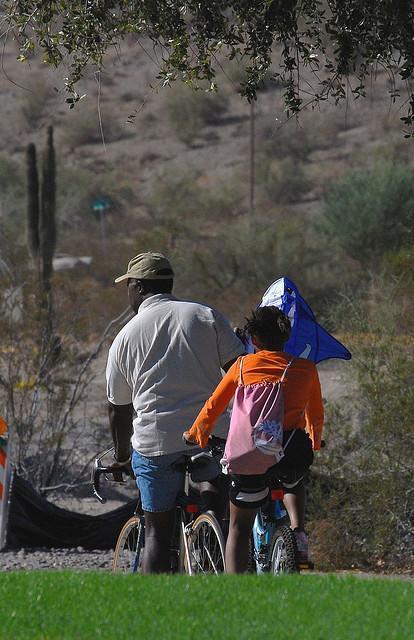How many adults are shown?
Give a very brief answer. 1. How many bicycles are in the picture?
Give a very brief answer. 2. How many people can be seen?
Give a very brief answer. 2. How many backpacks are visible?
Give a very brief answer. 1. 